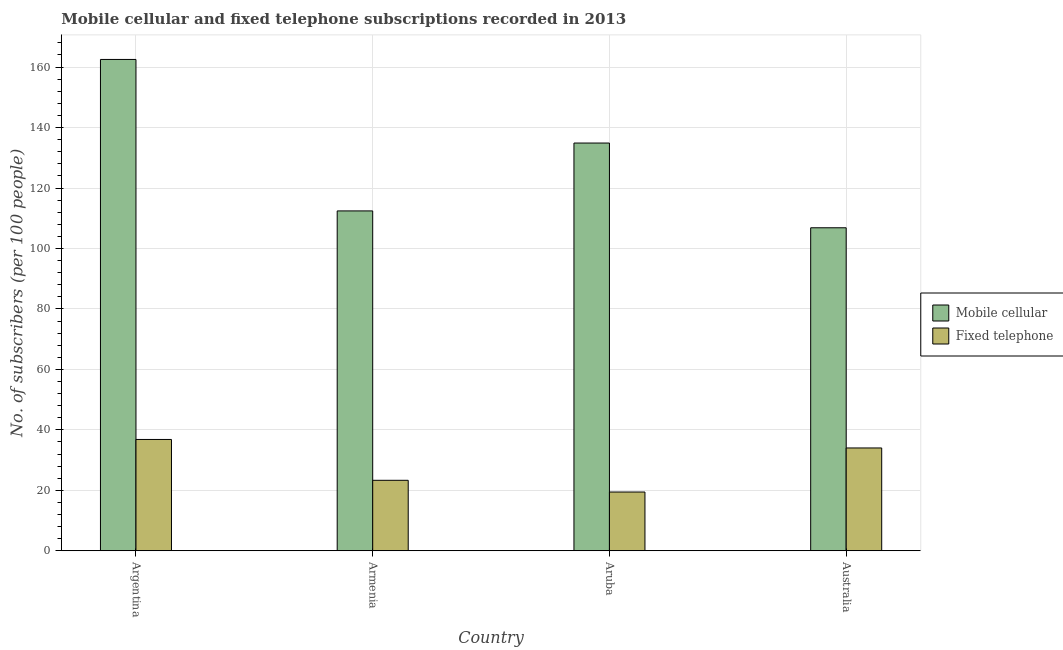Are the number of bars per tick equal to the number of legend labels?
Your answer should be very brief. Yes. Are the number of bars on each tick of the X-axis equal?
Give a very brief answer. Yes. How many bars are there on the 4th tick from the right?
Provide a short and direct response. 2. What is the label of the 3rd group of bars from the left?
Provide a short and direct response. Aruba. In how many cases, is the number of bars for a given country not equal to the number of legend labels?
Make the answer very short. 0. What is the number of mobile cellular subscribers in Armenia?
Your response must be concise. 112.42. Across all countries, what is the maximum number of fixed telephone subscribers?
Offer a terse response. 36.82. Across all countries, what is the minimum number of mobile cellular subscribers?
Provide a succinct answer. 106.84. In which country was the number of mobile cellular subscribers minimum?
Offer a terse response. Australia. What is the total number of mobile cellular subscribers in the graph?
Provide a short and direct response. 516.67. What is the difference between the number of mobile cellular subscribers in Aruba and that in Australia?
Keep it short and to the point. 28.03. What is the difference between the number of mobile cellular subscribers in Argentina and the number of fixed telephone subscribers in Aruba?
Your response must be concise. 143.09. What is the average number of fixed telephone subscribers per country?
Offer a terse response. 28.39. What is the difference between the number of mobile cellular subscribers and number of fixed telephone subscribers in Australia?
Make the answer very short. 72.83. In how many countries, is the number of fixed telephone subscribers greater than 128 ?
Offer a very short reply. 0. What is the ratio of the number of mobile cellular subscribers in Argentina to that in Armenia?
Provide a short and direct response. 1.45. Is the difference between the number of mobile cellular subscribers in Argentina and Armenia greater than the difference between the number of fixed telephone subscribers in Argentina and Armenia?
Offer a terse response. Yes. What is the difference between the highest and the second highest number of fixed telephone subscribers?
Make the answer very short. 2.81. What is the difference between the highest and the lowest number of fixed telephone subscribers?
Provide a short and direct response. 17.39. In how many countries, is the number of fixed telephone subscribers greater than the average number of fixed telephone subscribers taken over all countries?
Offer a very short reply. 2. Is the sum of the number of mobile cellular subscribers in Argentina and Aruba greater than the maximum number of fixed telephone subscribers across all countries?
Provide a short and direct response. Yes. What does the 1st bar from the left in Armenia represents?
Give a very brief answer. Mobile cellular. What does the 2nd bar from the right in Armenia represents?
Give a very brief answer. Mobile cellular. How many bars are there?
Your response must be concise. 8. Are all the bars in the graph horizontal?
Your answer should be compact. No. What is the difference between two consecutive major ticks on the Y-axis?
Give a very brief answer. 20. Are the values on the major ticks of Y-axis written in scientific E-notation?
Provide a succinct answer. No. Does the graph contain any zero values?
Your answer should be compact. No. Does the graph contain grids?
Provide a succinct answer. Yes. How many legend labels are there?
Offer a terse response. 2. What is the title of the graph?
Ensure brevity in your answer.  Mobile cellular and fixed telephone subscriptions recorded in 2013. What is the label or title of the X-axis?
Make the answer very short. Country. What is the label or title of the Y-axis?
Your response must be concise. No. of subscribers (per 100 people). What is the No. of subscribers (per 100 people) of Mobile cellular in Argentina?
Offer a terse response. 162.53. What is the No. of subscribers (per 100 people) of Fixed telephone in Argentina?
Offer a very short reply. 36.82. What is the No. of subscribers (per 100 people) in Mobile cellular in Armenia?
Make the answer very short. 112.42. What is the No. of subscribers (per 100 people) of Fixed telephone in Armenia?
Provide a succinct answer. 23.31. What is the No. of subscribers (per 100 people) of Mobile cellular in Aruba?
Provide a succinct answer. 134.87. What is the No. of subscribers (per 100 people) of Fixed telephone in Aruba?
Provide a short and direct response. 19.43. What is the No. of subscribers (per 100 people) in Mobile cellular in Australia?
Make the answer very short. 106.84. What is the No. of subscribers (per 100 people) in Fixed telephone in Australia?
Provide a succinct answer. 34.01. Across all countries, what is the maximum No. of subscribers (per 100 people) in Mobile cellular?
Offer a very short reply. 162.53. Across all countries, what is the maximum No. of subscribers (per 100 people) in Fixed telephone?
Make the answer very short. 36.82. Across all countries, what is the minimum No. of subscribers (per 100 people) of Mobile cellular?
Offer a very short reply. 106.84. Across all countries, what is the minimum No. of subscribers (per 100 people) of Fixed telephone?
Ensure brevity in your answer.  19.43. What is the total No. of subscribers (per 100 people) in Mobile cellular in the graph?
Give a very brief answer. 516.67. What is the total No. of subscribers (per 100 people) in Fixed telephone in the graph?
Make the answer very short. 113.58. What is the difference between the No. of subscribers (per 100 people) of Mobile cellular in Argentina and that in Armenia?
Provide a succinct answer. 50.11. What is the difference between the No. of subscribers (per 100 people) in Fixed telephone in Argentina and that in Armenia?
Your response must be concise. 13.51. What is the difference between the No. of subscribers (per 100 people) of Mobile cellular in Argentina and that in Aruba?
Your answer should be compact. 27.65. What is the difference between the No. of subscribers (per 100 people) of Fixed telephone in Argentina and that in Aruba?
Your response must be concise. 17.39. What is the difference between the No. of subscribers (per 100 people) of Mobile cellular in Argentina and that in Australia?
Offer a terse response. 55.68. What is the difference between the No. of subscribers (per 100 people) of Fixed telephone in Argentina and that in Australia?
Your answer should be very brief. 2.81. What is the difference between the No. of subscribers (per 100 people) in Mobile cellular in Armenia and that in Aruba?
Your answer should be very brief. -22.45. What is the difference between the No. of subscribers (per 100 people) of Fixed telephone in Armenia and that in Aruba?
Provide a succinct answer. 3.88. What is the difference between the No. of subscribers (per 100 people) of Mobile cellular in Armenia and that in Australia?
Make the answer very short. 5.58. What is the difference between the No. of subscribers (per 100 people) in Fixed telephone in Armenia and that in Australia?
Offer a terse response. -10.7. What is the difference between the No. of subscribers (per 100 people) in Mobile cellular in Aruba and that in Australia?
Provide a succinct answer. 28.03. What is the difference between the No. of subscribers (per 100 people) in Fixed telephone in Aruba and that in Australia?
Offer a terse response. -14.58. What is the difference between the No. of subscribers (per 100 people) of Mobile cellular in Argentina and the No. of subscribers (per 100 people) of Fixed telephone in Armenia?
Keep it short and to the point. 139.22. What is the difference between the No. of subscribers (per 100 people) in Mobile cellular in Argentina and the No. of subscribers (per 100 people) in Fixed telephone in Aruba?
Your answer should be very brief. 143.09. What is the difference between the No. of subscribers (per 100 people) in Mobile cellular in Argentina and the No. of subscribers (per 100 people) in Fixed telephone in Australia?
Ensure brevity in your answer.  128.52. What is the difference between the No. of subscribers (per 100 people) of Mobile cellular in Armenia and the No. of subscribers (per 100 people) of Fixed telephone in Aruba?
Ensure brevity in your answer.  92.99. What is the difference between the No. of subscribers (per 100 people) of Mobile cellular in Armenia and the No. of subscribers (per 100 people) of Fixed telephone in Australia?
Your answer should be very brief. 78.41. What is the difference between the No. of subscribers (per 100 people) in Mobile cellular in Aruba and the No. of subscribers (per 100 people) in Fixed telephone in Australia?
Offer a very short reply. 100.86. What is the average No. of subscribers (per 100 people) in Mobile cellular per country?
Ensure brevity in your answer.  129.17. What is the average No. of subscribers (per 100 people) of Fixed telephone per country?
Keep it short and to the point. 28.39. What is the difference between the No. of subscribers (per 100 people) in Mobile cellular and No. of subscribers (per 100 people) in Fixed telephone in Argentina?
Give a very brief answer. 125.71. What is the difference between the No. of subscribers (per 100 people) in Mobile cellular and No. of subscribers (per 100 people) in Fixed telephone in Armenia?
Make the answer very short. 89.11. What is the difference between the No. of subscribers (per 100 people) in Mobile cellular and No. of subscribers (per 100 people) in Fixed telephone in Aruba?
Your answer should be very brief. 115.44. What is the difference between the No. of subscribers (per 100 people) in Mobile cellular and No. of subscribers (per 100 people) in Fixed telephone in Australia?
Provide a short and direct response. 72.83. What is the ratio of the No. of subscribers (per 100 people) of Mobile cellular in Argentina to that in Armenia?
Provide a succinct answer. 1.45. What is the ratio of the No. of subscribers (per 100 people) in Fixed telephone in Argentina to that in Armenia?
Offer a terse response. 1.58. What is the ratio of the No. of subscribers (per 100 people) of Mobile cellular in Argentina to that in Aruba?
Your answer should be very brief. 1.21. What is the ratio of the No. of subscribers (per 100 people) of Fixed telephone in Argentina to that in Aruba?
Provide a succinct answer. 1.89. What is the ratio of the No. of subscribers (per 100 people) of Mobile cellular in Argentina to that in Australia?
Your answer should be compact. 1.52. What is the ratio of the No. of subscribers (per 100 people) of Fixed telephone in Argentina to that in Australia?
Give a very brief answer. 1.08. What is the ratio of the No. of subscribers (per 100 people) of Mobile cellular in Armenia to that in Aruba?
Offer a terse response. 0.83. What is the ratio of the No. of subscribers (per 100 people) in Fixed telephone in Armenia to that in Aruba?
Ensure brevity in your answer.  1.2. What is the ratio of the No. of subscribers (per 100 people) in Mobile cellular in Armenia to that in Australia?
Provide a succinct answer. 1.05. What is the ratio of the No. of subscribers (per 100 people) in Fixed telephone in Armenia to that in Australia?
Make the answer very short. 0.69. What is the ratio of the No. of subscribers (per 100 people) of Mobile cellular in Aruba to that in Australia?
Make the answer very short. 1.26. What is the difference between the highest and the second highest No. of subscribers (per 100 people) of Mobile cellular?
Your answer should be compact. 27.65. What is the difference between the highest and the second highest No. of subscribers (per 100 people) of Fixed telephone?
Offer a terse response. 2.81. What is the difference between the highest and the lowest No. of subscribers (per 100 people) in Mobile cellular?
Ensure brevity in your answer.  55.68. What is the difference between the highest and the lowest No. of subscribers (per 100 people) in Fixed telephone?
Make the answer very short. 17.39. 